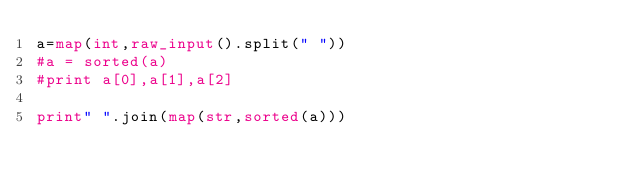Convert code to text. <code><loc_0><loc_0><loc_500><loc_500><_Python_>a=map(int,raw_input().split(" "))
#a = sorted(a)
#print a[0],a[1],a[2]

print" ".join(map(str,sorted(a)))</code> 